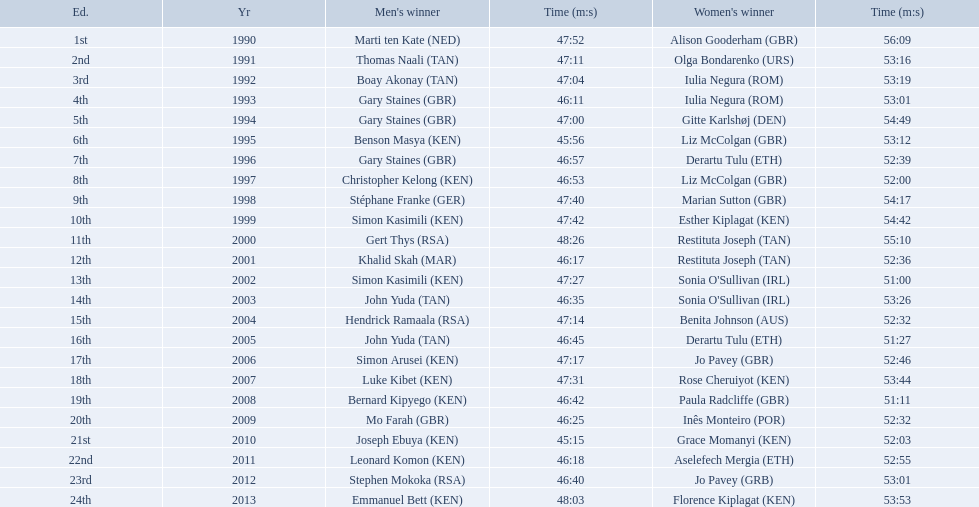Which runners are from kenya? (ken) Benson Masya (KEN), Christopher Kelong (KEN), Simon Kasimili (KEN), Simon Kasimili (KEN), Simon Arusei (KEN), Luke Kibet (KEN), Bernard Kipyego (KEN), Joseph Ebuya (KEN), Leonard Komon (KEN), Emmanuel Bett (KEN). Of these, which times are under 46 minutes? Benson Masya (KEN), Joseph Ebuya (KEN). Which of these runners had the faster time? Joseph Ebuya (KEN). Who were all the runners' times between 1990 and 2013? 47:52, 56:09, 47:11, 53:16, 47:04, 53:19, 46:11, 53:01, 47:00, 54:49, 45:56, 53:12, 46:57, 52:39, 46:53, 52:00, 47:40, 54:17, 47:42, 54:42, 48:26, 55:10, 46:17, 52:36, 47:27, 51:00, 46:35, 53:26, 47:14, 52:32, 46:45, 51:27, 47:17, 52:46, 47:31, 53:44, 46:42, 51:11, 46:25, 52:32, 45:15, 52:03, 46:18, 52:55, 46:40, 53:01, 48:03, 53:53. Which was the fastest time? 45:15. Who ran that time? Joseph Ebuya (KEN). 